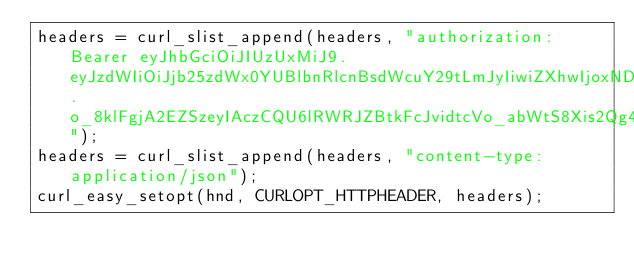Convert code to text. <code><loc_0><loc_0><loc_500><loc_500><_C_>headers = curl_slist_append(headers, "authorization: Bearer eyJhbGciOiJIUzUxMiJ9.eyJzdWIiOiJjb25zdWx0YUBlbnRlcnBsdWcuY29tLmJyIiwiZXhwIjoxNDcwOTM2Njg1fQ.o_8klFgjA2EZSzeyIAczCQU6lRWRJZBtkFcJvidtcVo_abWtS8Xis2Qg4C3aArCIYTyZjr3aPLb4LSd9aqzFFQ");
headers = curl_slist_append(headers, "content-type: application/json");
curl_easy_setopt(hnd, CURLOPT_HTTPHEADER, headers);
</code> 